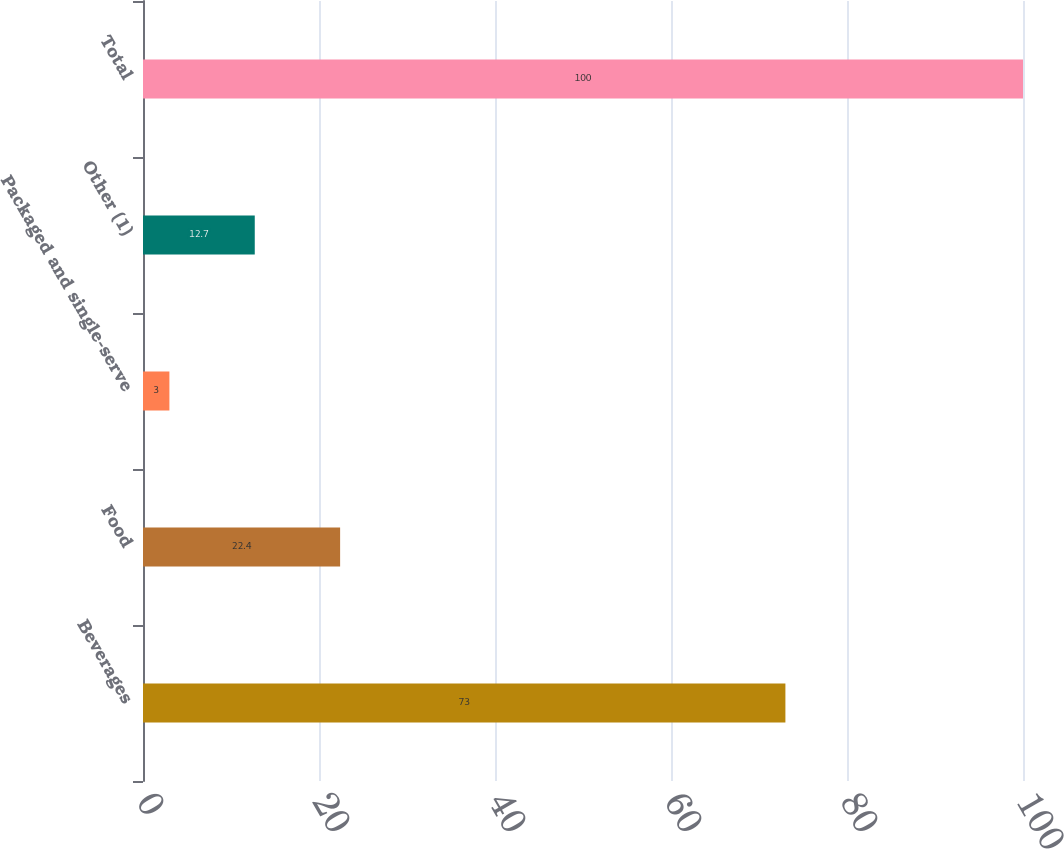Convert chart. <chart><loc_0><loc_0><loc_500><loc_500><bar_chart><fcel>Beverages<fcel>Food<fcel>Packaged and single-serve<fcel>Other (1)<fcel>Total<nl><fcel>73<fcel>22.4<fcel>3<fcel>12.7<fcel>100<nl></chart> 